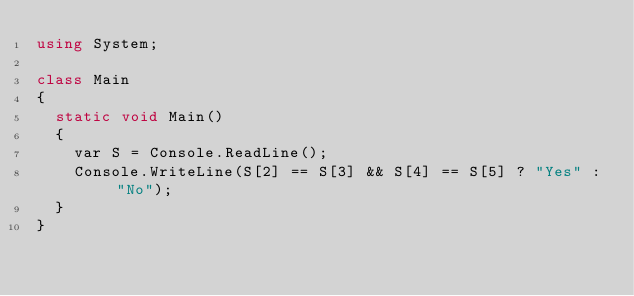Convert code to text. <code><loc_0><loc_0><loc_500><loc_500><_C#_>using System;

class Main
{
  static void Main()
  {
    var S = Console.ReadLine();
    Console.WriteLine(S[2] == S[3] && S[4] == S[5] ? "Yes" : "No");
  }
}</code> 